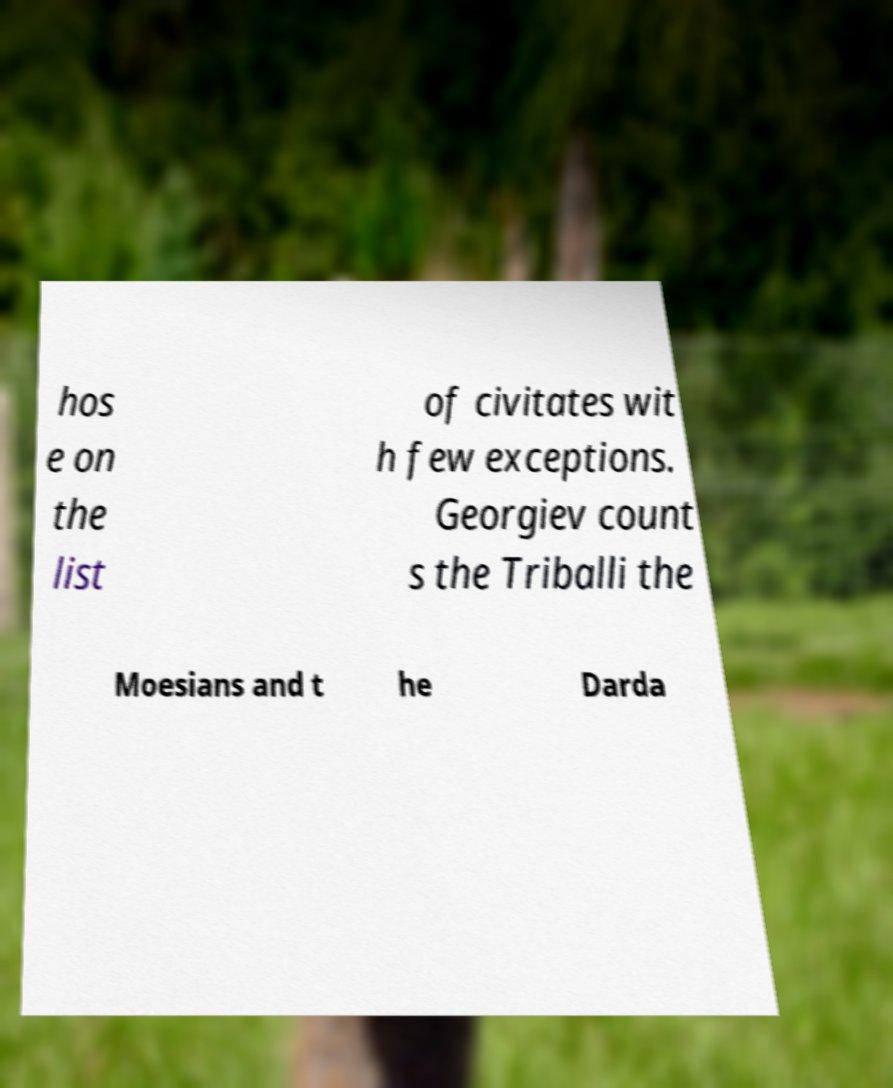Can you accurately transcribe the text from the provided image for me? hos e on the list of civitates wit h few exceptions. Georgiev count s the Triballi the Moesians and t he Darda 